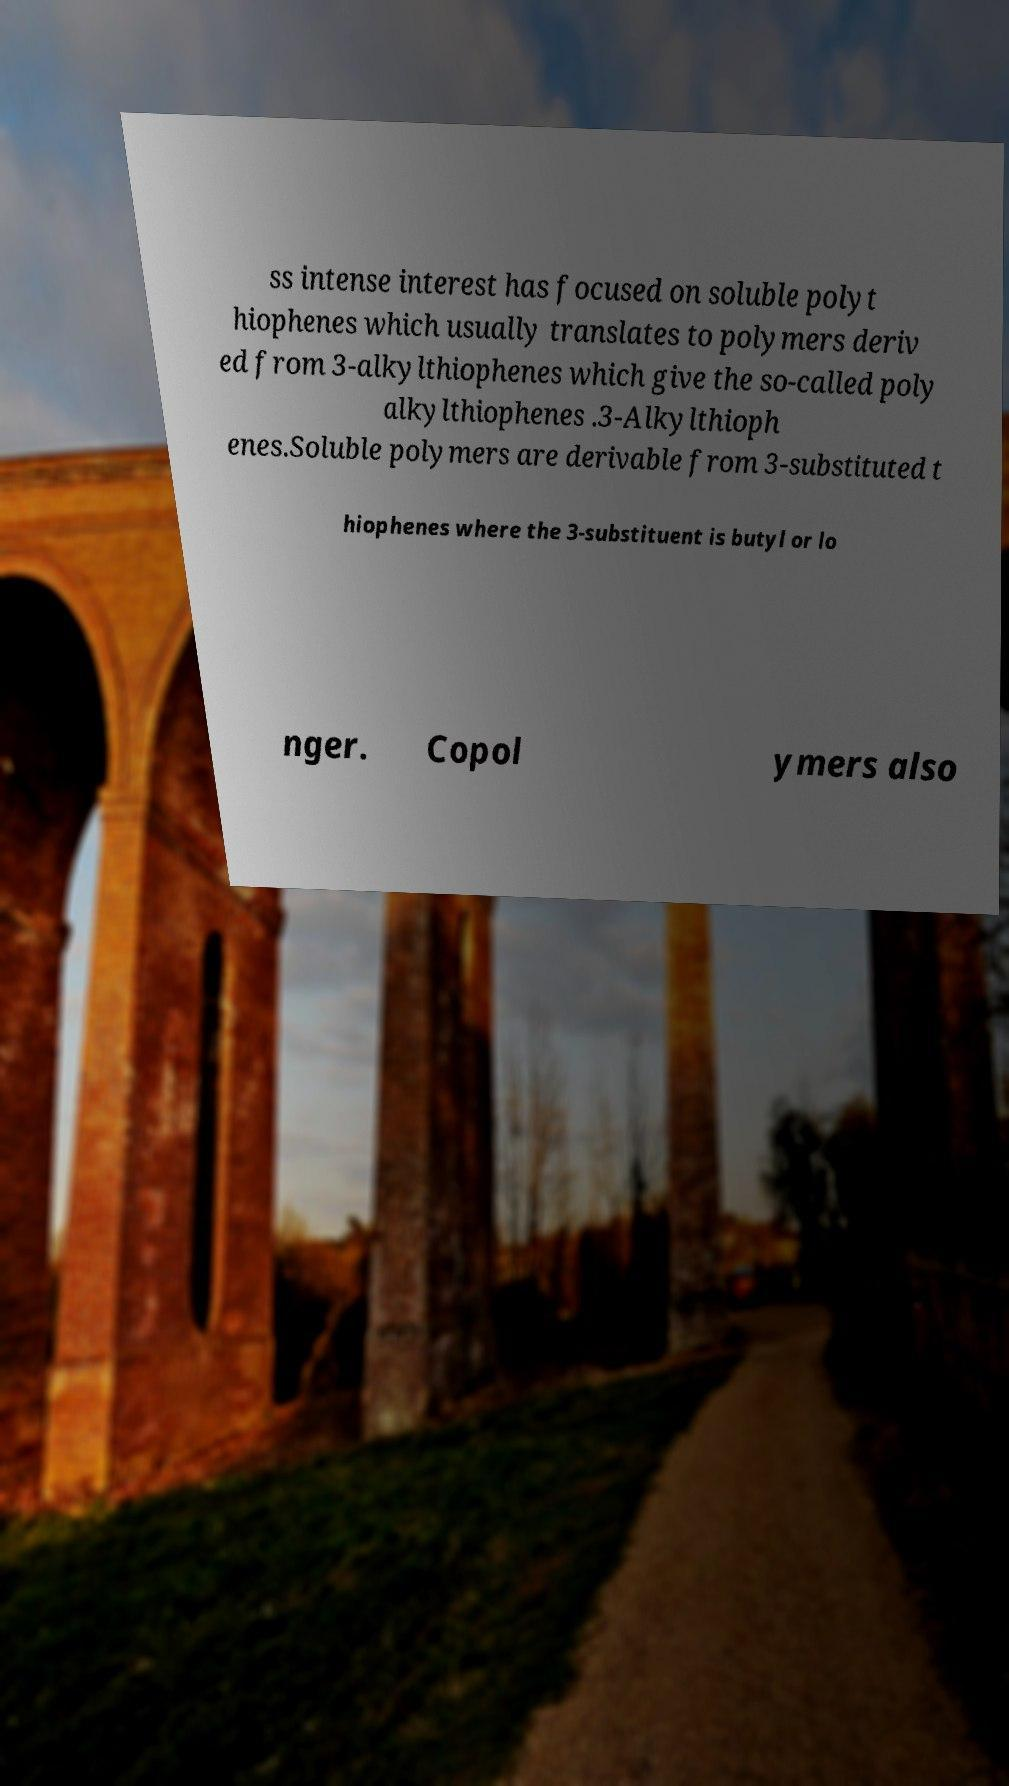Could you extract and type out the text from this image? ss intense interest has focused on soluble polyt hiophenes which usually translates to polymers deriv ed from 3-alkylthiophenes which give the so-called poly alkylthiophenes .3-Alkylthioph enes.Soluble polymers are derivable from 3-substituted t hiophenes where the 3-substituent is butyl or lo nger. Copol ymers also 